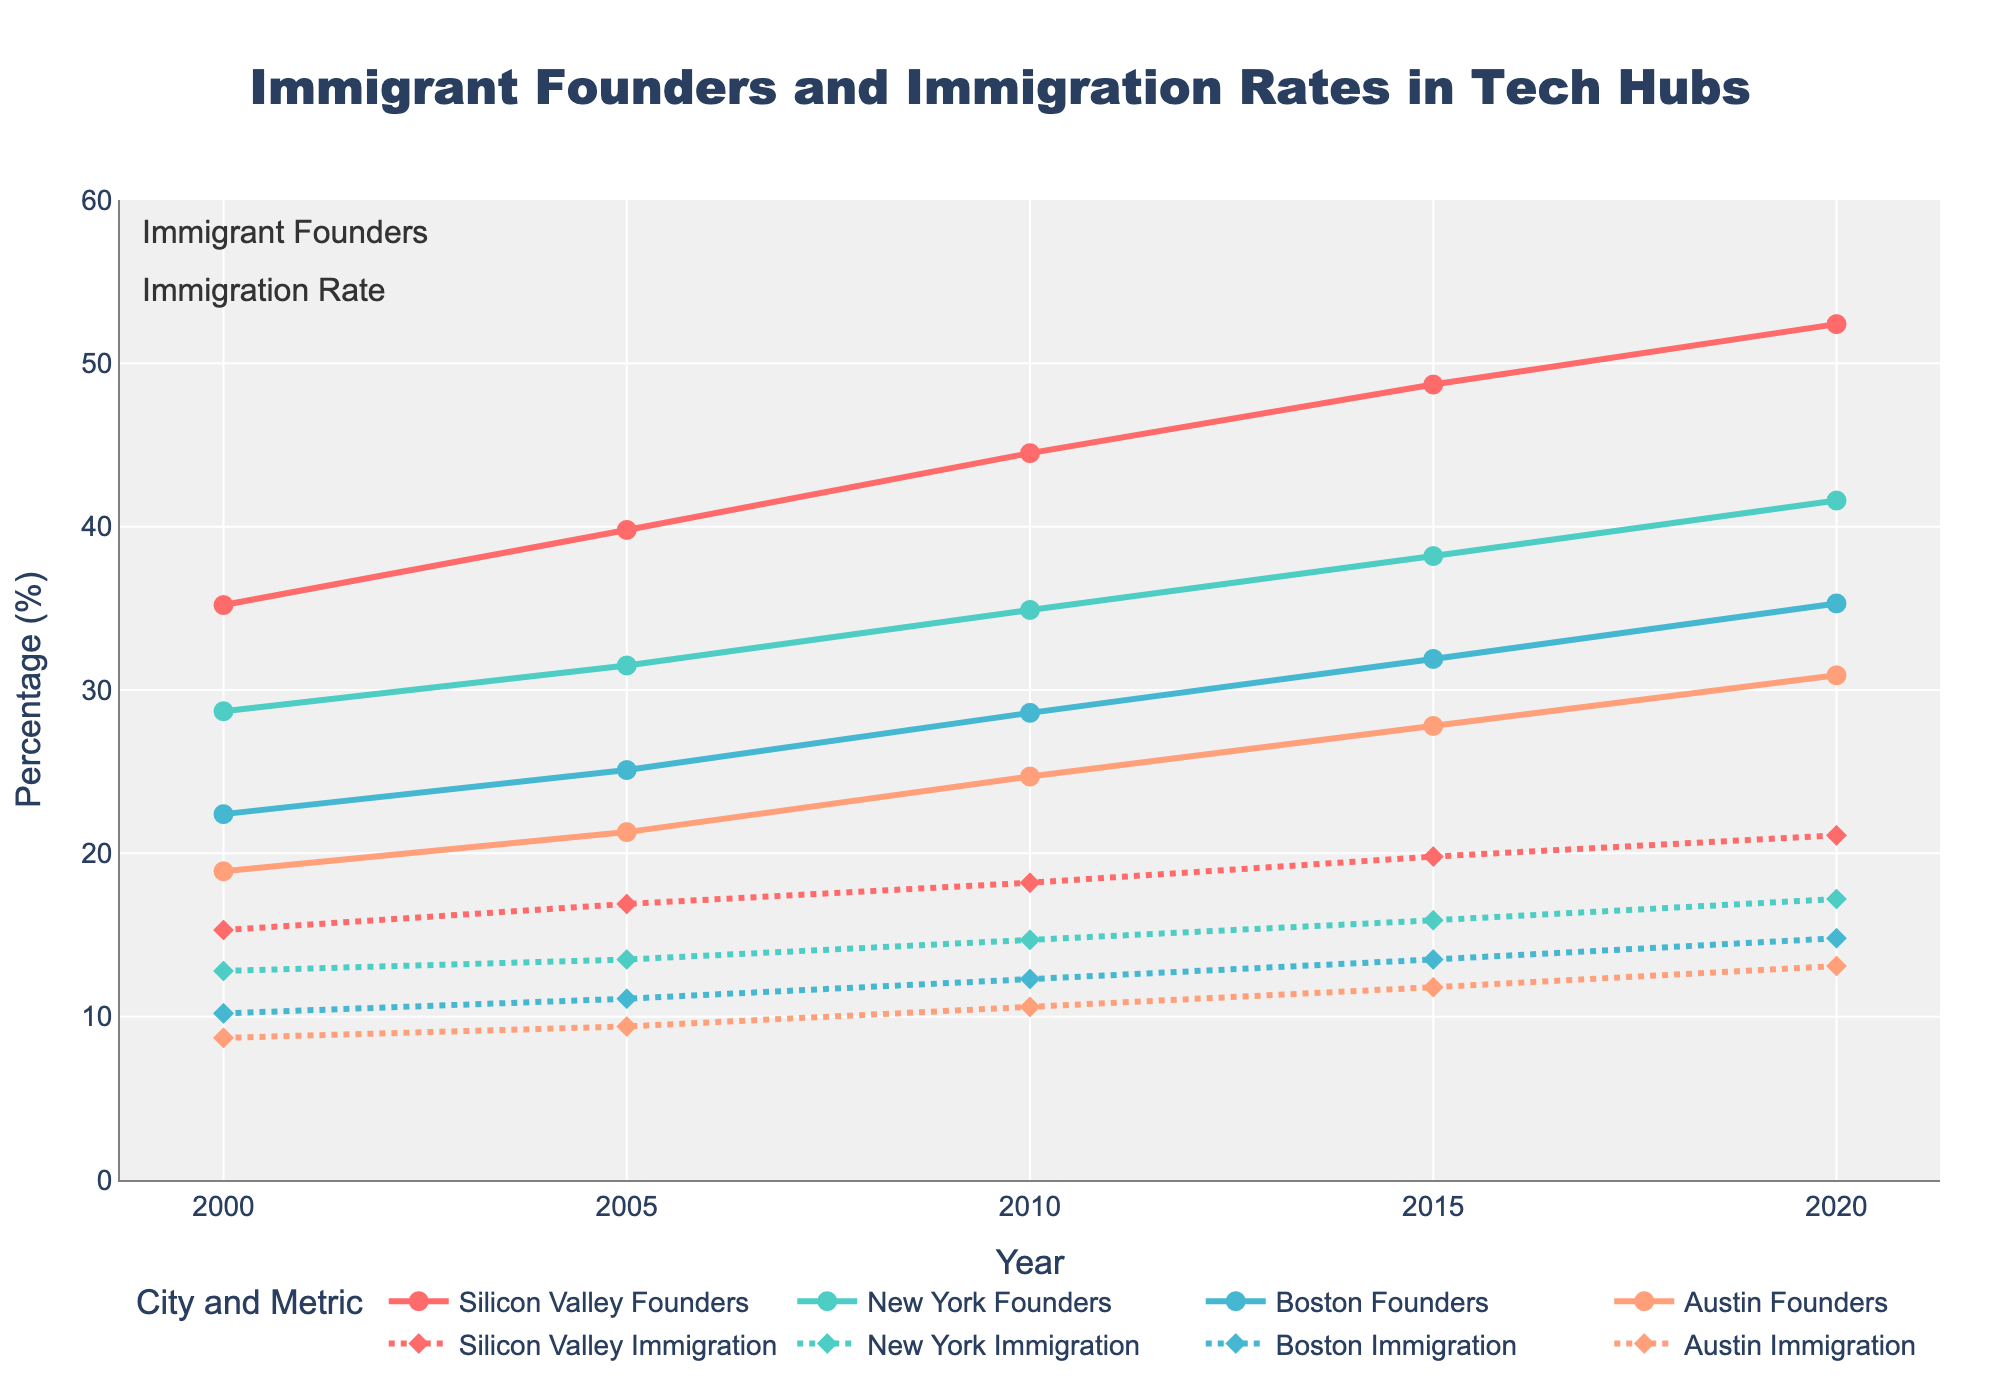What is the title of the figure? The title is clearly displayed at the top of the figure.
Answer: Immigrant Founders and Immigration Rates in Tech Hubs Which tech hub had the highest percentage of immigrant founders in 2020? Locate the line representing "Immigrant Founders" for each city in 2020 and compare their values. Silicon Valley has the highest percentage.
Answer: Silicon Valley Did the percentage of immigrant founders increase or decrease in Austin from 2005 to 2015? Identify the "Austin Immigrant Founders (%)" data points for 2005 and 2015 on the line chart, and note the trend between these two years. The percentage increased.
Answer: Increased What is the range of the y-axis in the figure? Look at the y-axis on the left side of the chart and identify its minimum and maximum values.
Answer: 0 to 60 What is the average percentage of immigrant founders in New York over the years 2000, 2005, and 2010? Extract the values for "New York Immigrant Founders (%)" for 2000, 2005, and 2010, sum them up and divide by 3. (28.7 + 31.5 + 34.9) / 3 = 31.7
Answer: 31.7% How does the trend of the immigration rate in Silicon Valley compare to its trend of immigrant founders from 2000 to 2020? Compare the slope and direction of the "Silicon Valley Immigration Rate" and "Silicon Valley Immigrant Founders (%)" lines from 2000 to 2020. Both increase, but the founders' line shows a steeper ascent, indicating a faster growth rate.
Answer: Both increased, but founders faster Which city showed the smallest increase in immigrant founders' percentage from 2000 to 2020? Calculate the difference in percentages for each city between 2000 and 2020 and identify the smallest one. Austin increased from 18.9% to 30.9%, which is an increase of 12%.
Answer: Austin What was the immigration rate in New York in 2015? Find the data point on the New York Immigration Rate line for the year 2015.
Answer: 15.9% Which city had the most similar trends for immigrant founders' percentage and immigration rate? Look for cities where the two lines (founders and immigration rate) follow a similar pattern in direction and slope.
Answer: Silicon Valley What is the overall trend in the percentage of immigrant founders across all cities from 2000 to 2020? Observe the direction in which the lines for all cities representing "Immigrant Founders" move over the years from 2000 to 2020. All lines show an upward trend.
Answer: Increasing 